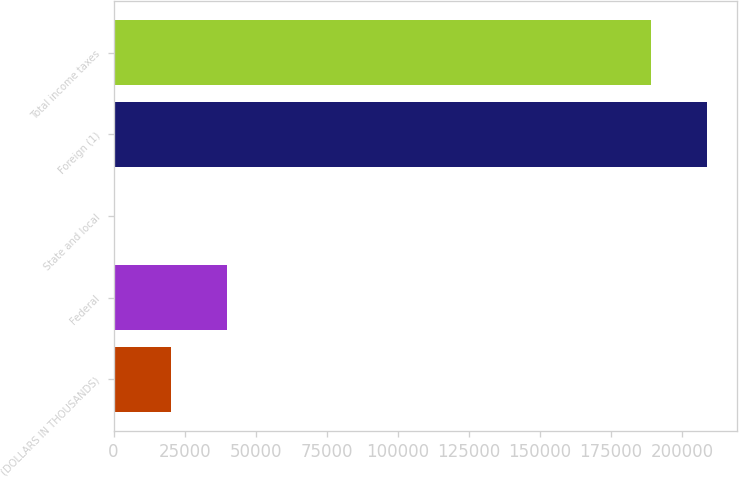<chart> <loc_0><loc_0><loc_500><loc_500><bar_chart><fcel>(DOLLARS IN THOUSANDS)<fcel>Federal<fcel>State and local<fcel>Foreign (1)<fcel>Total income taxes<nl><fcel>20143.9<fcel>39831.8<fcel>456<fcel>208969<fcel>189281<nl></chart> 